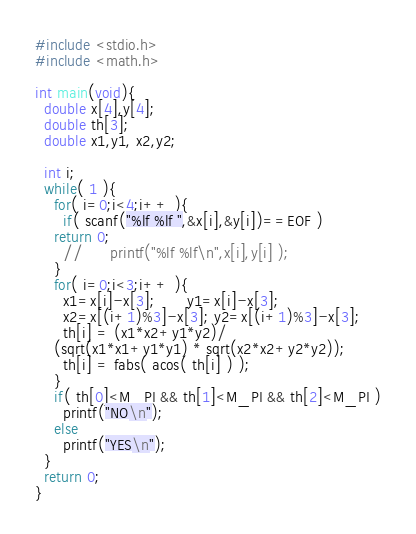<code> <loc_0><loc_0><loc_500><loc_500><_C_>#include <stdio.h>
#include <math.h>

int main(void){
  double x[4],y[4];
  double th[3];
  double x1,y1, x2,y2;

  int i;
  while( 1 ){
    for( i=0;i<4;i++ ){
      if( scanf("%lf %lf ",&x[i],&y[i])==EOF )
	return 0;
      //      printf("%lf %lf\n",x[i],y[i] );
    }
    for( i=0;i<3;i++ ){
      x1=x[i]-x[3];       y1=x[i]-x[3];
      x2=x[(i+1)%3]-x[3]; y2=x[(i+1)%3]-x[3];
      th[i] = (x1*x2+y1*y2)/
	(sqrt(x1*x1+y1*y1) * sqrt(x2*x2+y2*y2));
      th[i] = fabs( acos( th[i] ) );
    }
    if( th[0]<M_PI && th[1]<M_PI && th[2]<M_PI )
      printf("NO\n");
    else
      printf("YES\n");
  }
  return 0;
}</code> 